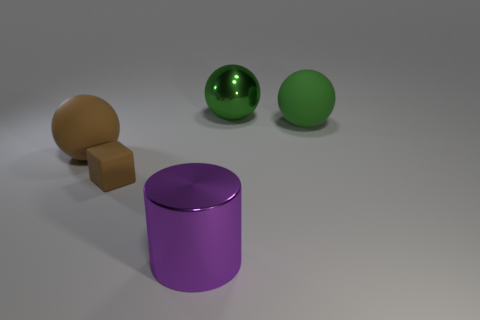Subtract all big green spheres. How many spheres are left? 1 Add 4 big brown rubber things. How many objects exist? 9 Subtract all cylinders. How many objects are left? 4 Subtract all green spheres. How many spheres are left? 1 Subtract 2 spheres. How many spheres are left? 1 Subtract all gray blocks. How many green spheres are left? 2 Subtract all small matte cubes. Subtract all large purple metal cylinders. How many objects are left? 3 Add 5 brown spheres. How many brown spheres are left? 6 Add 1 tiny brown objects. How many tiny brown objects exist? 2 Subtract 0 yellow cubes. How many objects are left? 5 